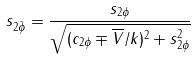Convert formula to latex. <formula><loc_0><loc_0><loc_500><loc_500>s _ { 2 \bar { \phi } } = \frac { s _ { 2 \phi } } { \sqrt { ( c _ { 2 \phi } \mp \overline { V } / k ) ^ { 2 } + s ^ { 2 } _ { 2 \phi } } }</formula> 